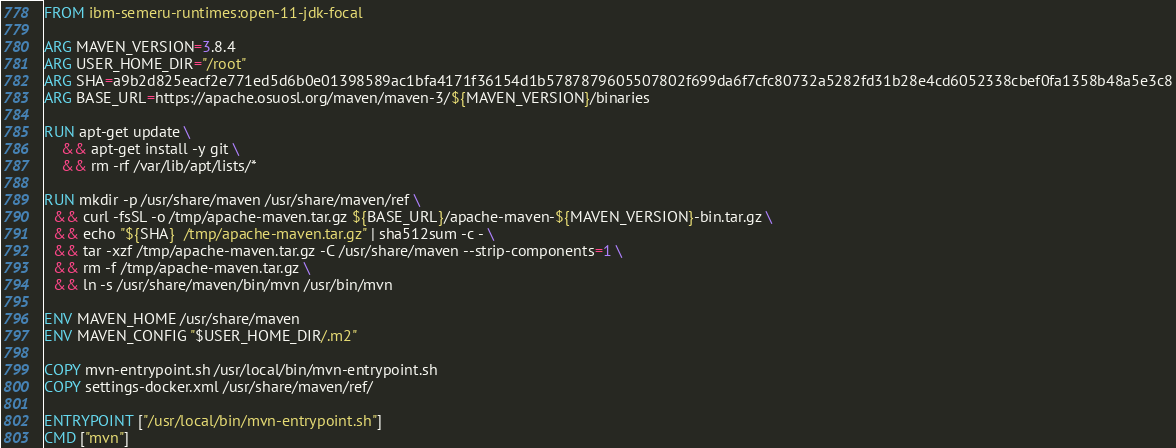Convert code to text. <code><loc_0><loc_0><loc_500><loc_500><_Dockerfile_>FROM ibm-semeru-runtimes:open-11-jdk-focal

ARG MAVEN_VERSION=3.8.4
ARG USER_HOME_DIR="/root"
ARG SHA=a9b2d825eacf2e771ed5d6b0e01398589ac1bfa4171f36154d1b5787879605507802f699da6f7cfc80732a5282fd31b28e4cd6052338cbef0fa1358b48a5e3c8
ARG BASE_URL=https://apache.osuosl.org/maven/maven-3/${MAVEN_VERSION}/binaries

RUN apt-get update \
    && apt-get install -y git \
    && rm -rf /var/lib/apt/lists/*

RUN mkdir -p /usr/share/maven /usr/share/maven/ref \
  && curl -fsSL -o /tmp/apache-maven.tar.gz ${BASE_URL}/apache-maven-${MAVEN_VERSION}-bin.tar.gz \
  && echo "${SHA}  /tmp/apache-maven.tar.gz" | sha512sum -c - \
  && tar -xzf /tmp/apache-maven.tar.gz -C /usr/share/maven --strip-components=1 \
  && rm -f /tmp/apache-maven.tar.gz \
  && ln -s /usr/share/maven/bin/mvn /usr/bin/mvn

ENV MAVEN_HOME /usr/share/maven
ENV MAVEN_CONFIG "$USER_HOME_DIR/.m2"

COPY mvn-entrypoint.sh /usr/local/bin/mvn-entrypoint.sh
COPY settings-docker.xml /usr/share/maven/ref/

ENTRYPOINT ["/usr/local/bin/mvn-entrypoint.sh"]
CMD ["mvn"]
</code> 